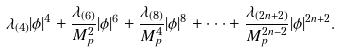Convert formula to latex. <formula><loc_0><loc_0><loc_500><loc_500>\lambda _ { ( 4 ) } | \phi | ^ { 4 } + \frac { \lambda _ { ( 6 ) } } { M _ { p } ^ { 2 } } | \phi | ^ { 6 } + \frac { \lambda _ { ( 8 ) } } { M _ { p } ^ { 4 } } | \phi | ^ { 8 } + \cdot \cdot \cdot + \frac { \lambda _ { ( 2 n + 2 ) } } { M _ { p } ^ { 2 n - 2 } } | \phi | ^ { 2 n + 2 } .</formula> 